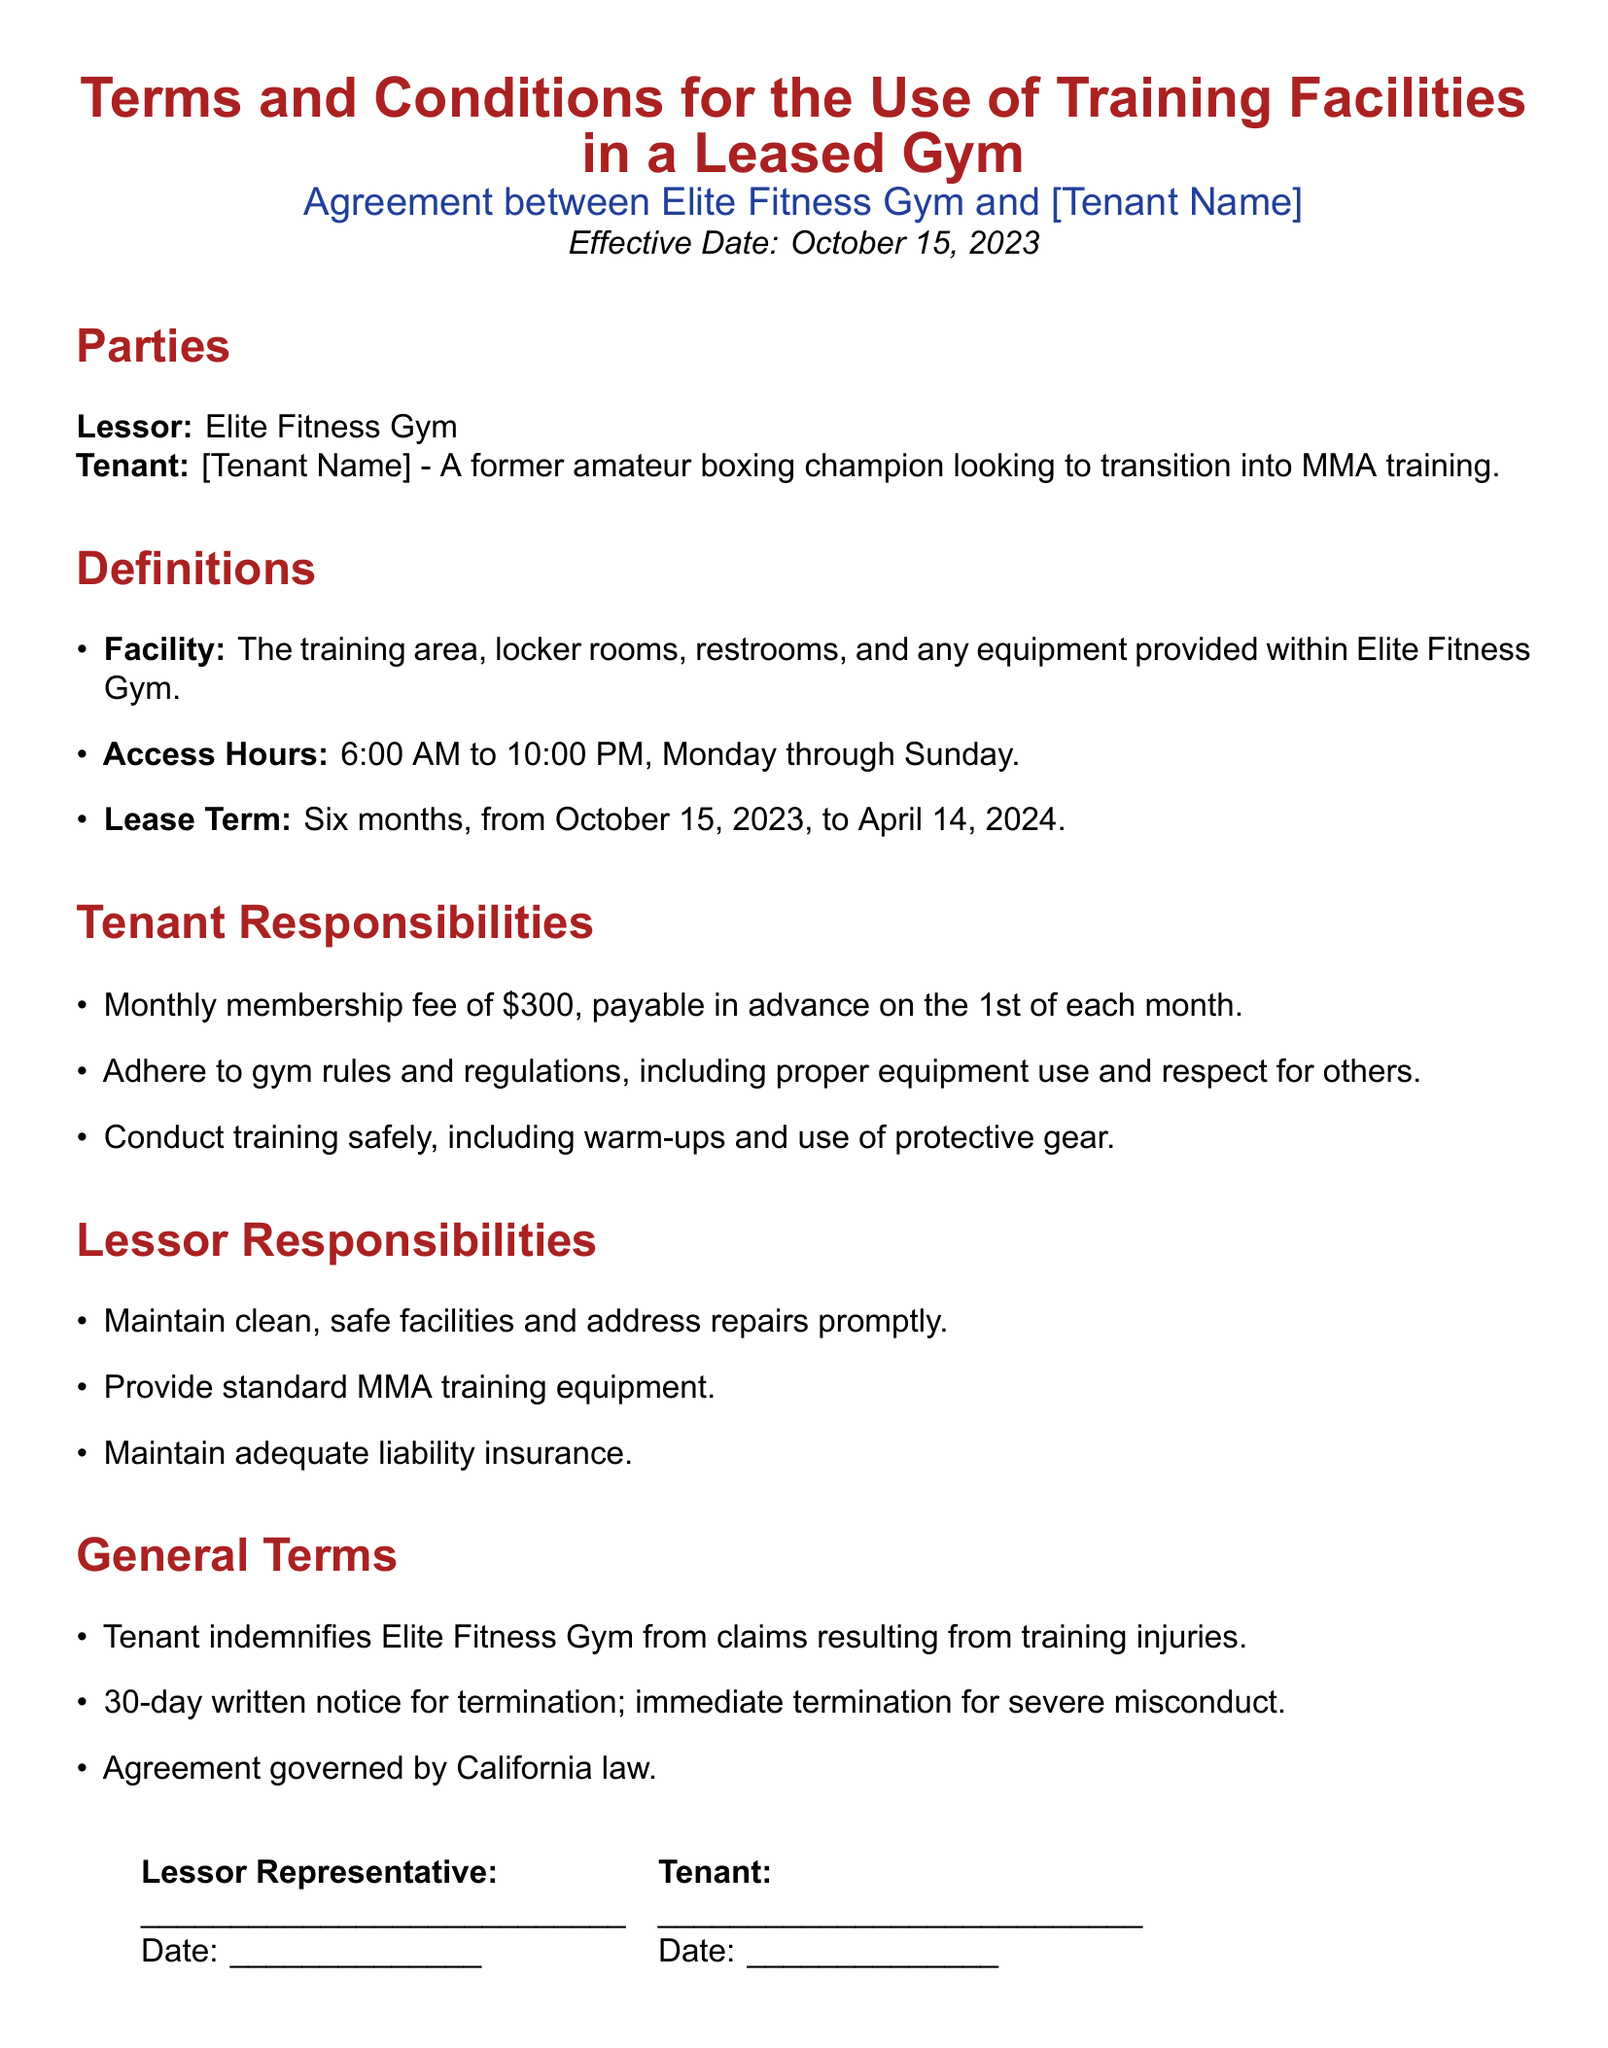What is the effective date of the agreement? The effective date of the agreement is specified at the beginning of the document.
Answer: October 15, 2023 What is included in the Facility? The document defines the Facility and lists its components.
Answer: Training area, locker rooms, restrooms, and any equipment provided What is the monthly membership fee? The document states the amount the tenant must pay monthly.
Answer: $300 What are the access hours? The access hours are defined within the document.
Answer: 6:00 AM to 10:00 PM What is the Lease Term? The Lease Term specifies the duration of the agreement.
Answer: Six months What responsibility does the Tenant have regarding training? The document outlines the responsibilities of the Tenant, including a specific requirement.
Answer: Conduct training safely What is the notice period for termination? The agreement specifies how much notice is needed if the Tenant wishes to terminate.
Answer: 30-day written notice Who is the Lessor? The Lessor is named in the "Parties" section of the document.
Answer: Elite Fitness Gym What type of insurance must the Lessor maintain? The document mentions this insurance requirement under Lessor Responsibilities.
Answer: Adequate liability insurance What law governs the agreement? The governing law of the agreement is specified at the end of the General Terms section.
Answer: California law 